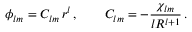<formula> <loc_0><loc_0><loc_500><loc_500>\phi _ { l m } = C _ { l m } \, r ^ { l } \, , \quad C _ { l m } = - \frac { \chi _ { l m } } { l R ^ { l + 1 } } \, .</formula> 